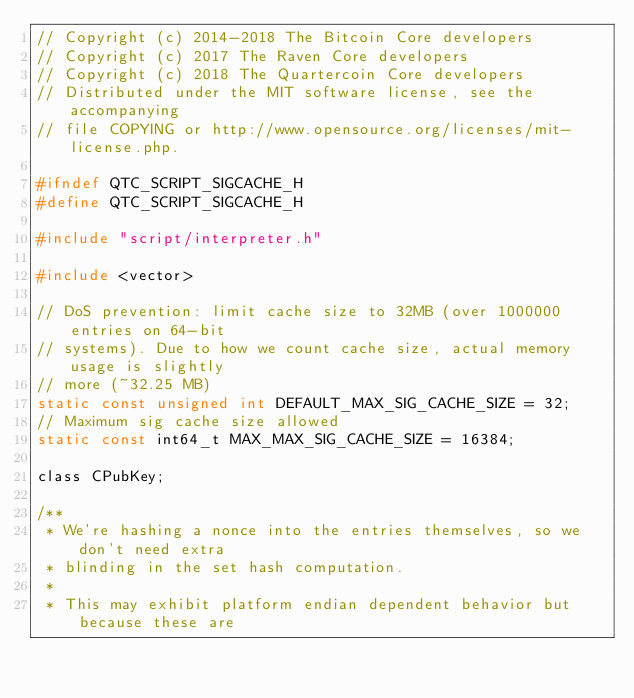Convert code to text. <code><loc_0><loc_0><loc_500><loc_500><_C_>// Copyright (c) 2014-2018 The Bitcoin Core developers
// Copyright (c) 2017 The Raven Core developers
// Copyright (c) 2018 The Quartercoin Core developers
// Distributed under the MIT software license, see the accompanying
// file COPYING or http://www.opensource.org/licenses/mit-license.php.

#ifndef QTC_SCRIPT_SIGCACHE_H
#define QTC_SCRIPT_SIGCACHE_H

#include "script/interpreter.h"

#include <vector>

// DoS prevention: limit cache size to 32MB (over 1000000 entries on 64-bit
// systems). Due to how we count cache size, actual memory usage is slightly
// more (~32.25 MB)
static const unsigned int DEFAULT_MAX_SIG_CACHE_SIZE = 32;
// Maximum sig cache size allowed
static const int64_t MAX_MAX_SIG_CACHE_SIZE = 16384;

class CPubKey;

/**
 * We're hashing a nonce into the entries themselves, so we don't need extra
 * blinding in the set hash computation.
 *
 * This may exhibit platform endian dependent behavior but because these are</code> 